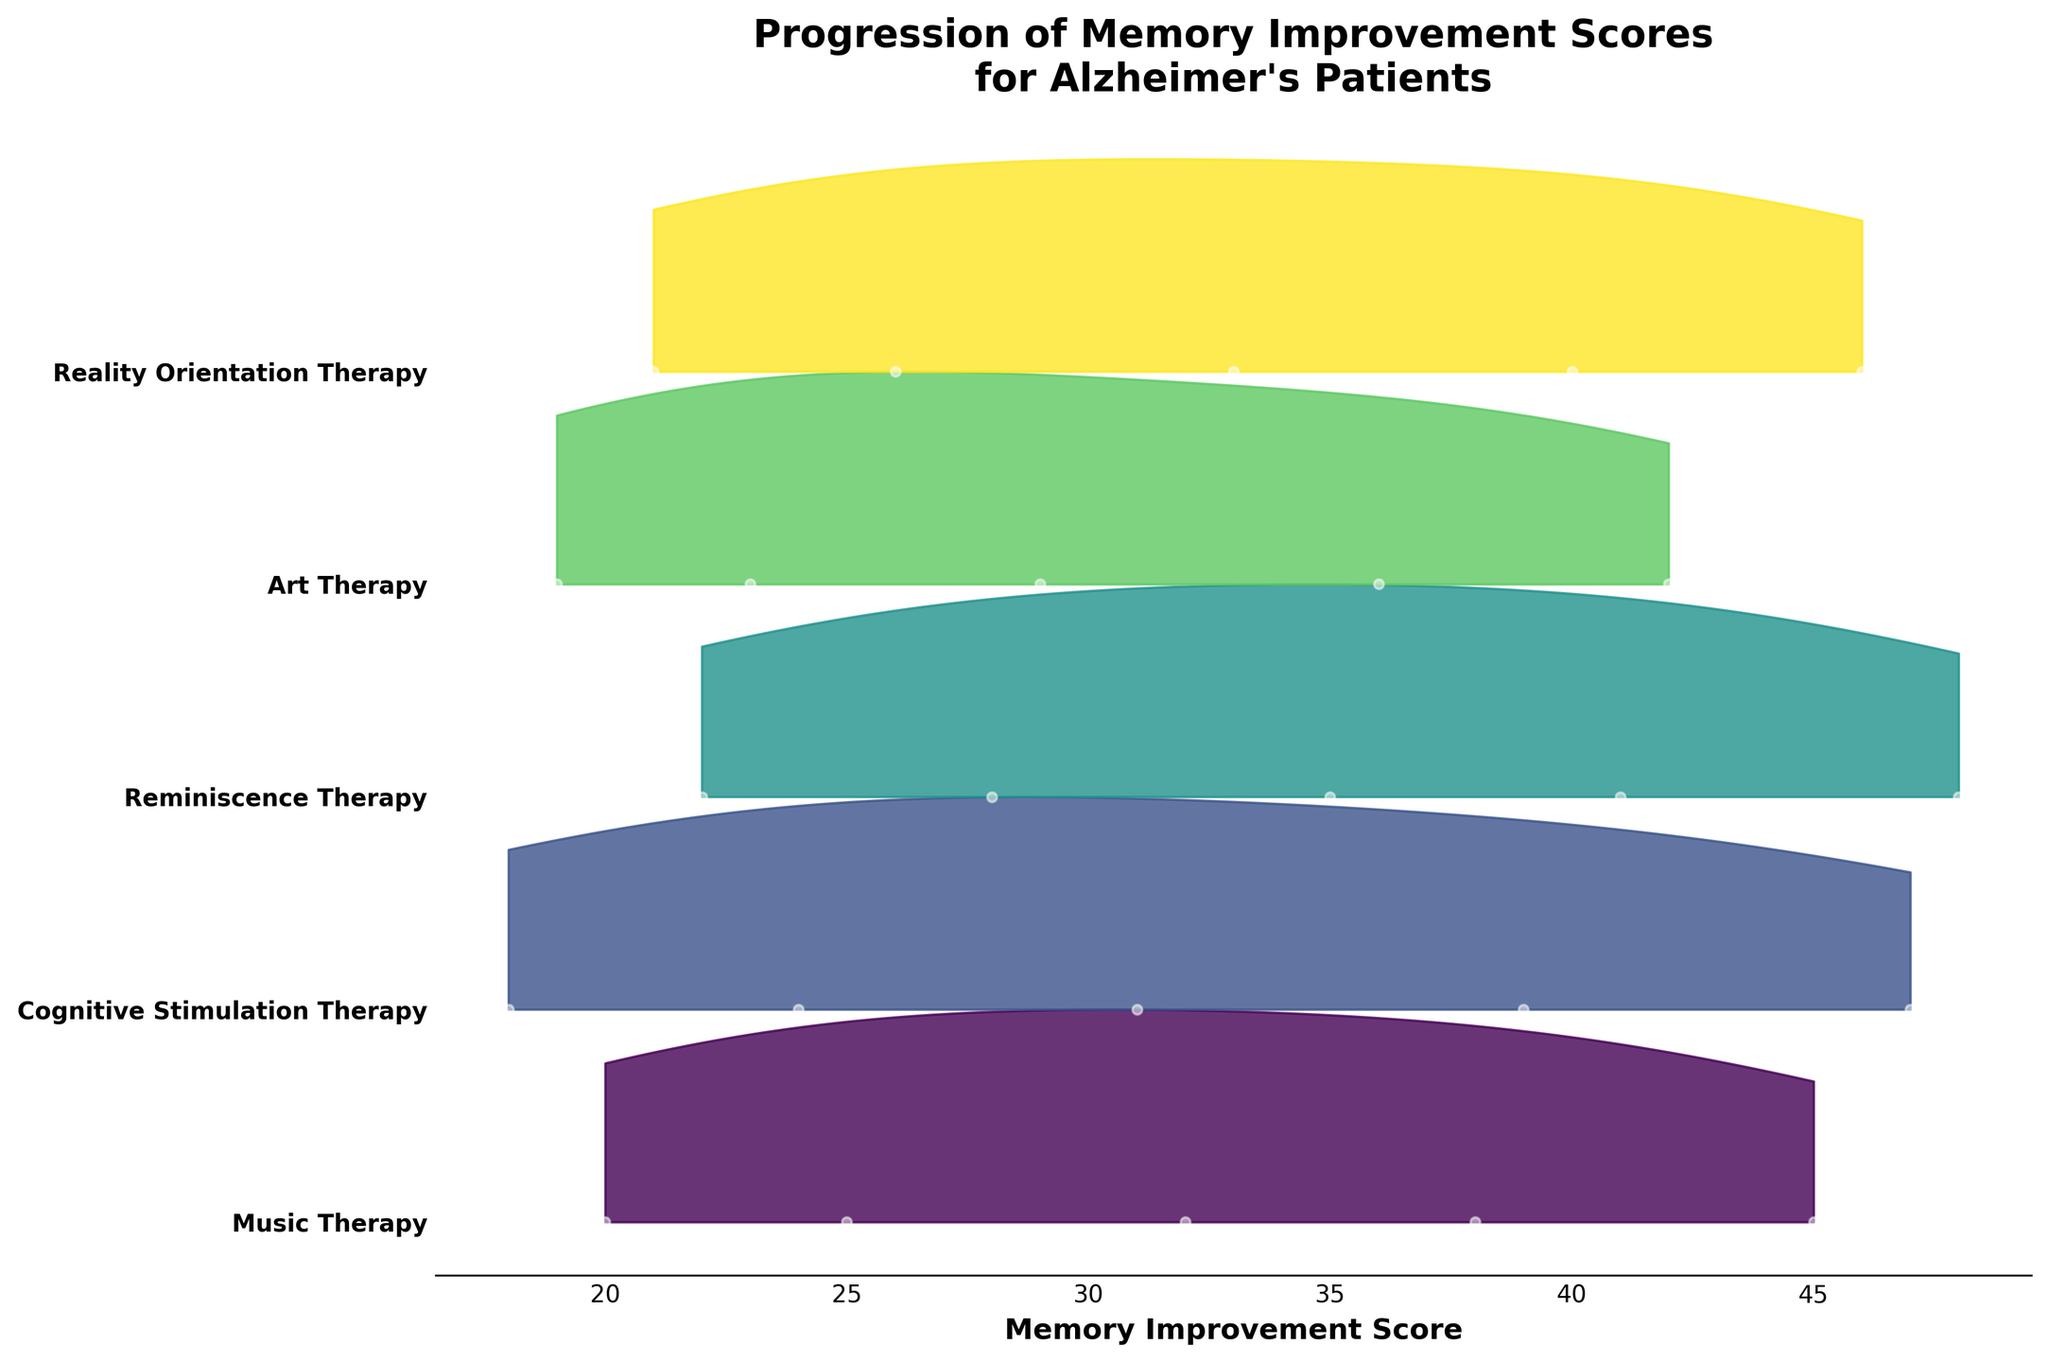what is the title of the plot? The title of the plot is displayed at the top and it reads "Progression of Memory Improvement Scores for Alzheimer's Patients"
Answer: Progression of Memory Improvement Scores for Alzheimer's Patients how many types of therapies are compared in this plot? By looking at the y-axis ticks, we can count the number of unique therapy types listed
Answer: Five which therapy type shows the highest memory improvement score at week 16? Identify the therapy where the highest data point on the x-axis corresponds to week 16
Answer: Reminiscence Therapy between Music Therapy and Art Therapy, which has higher memory improvement scores at week 12? Find the memory improvement scores at week 12 for both Music Therapy and Art Therapy and compare them
Answer: Music Therapy which therapy type shows the widest range of memory improvement scores? Assess the spread of scores for each therapy by looking at the area covered by each ridgeline
Answer: Cognitive Stimulation Therapy what is the average memory improvement score for Reality Orientation Therapy? Sum all the scores for Reality Orientation Therapy and divide by the number of data points for this therapy
Answer: 33.2 what is the median memory improvement score for Cognitive Stimulation Therapy at week 8? The median score would be the middle value of scores for Cognitive Stimulation Therapy at week 8. In this case, since only one value is present, it's the given score
Answer: 31 how does the score progression for Music Therapy compare to Art Therapy over the weeks? By comparing the scores from week 1 to week 16 for both therapies and noting the trends
Answer: Music Therapy generally shows higher improvement which therapy type shows the most consistent improvement in memory score over the weeks? Look for the therapy with evenly increasing score values over the weeks
Answer: Reality Orientation Therapy at week 4, which therapy has the lowest memory improvement score? Compare the memory improvement scores of all therapies at week 4 and identify the lowest one
Answer: Art Therapy 